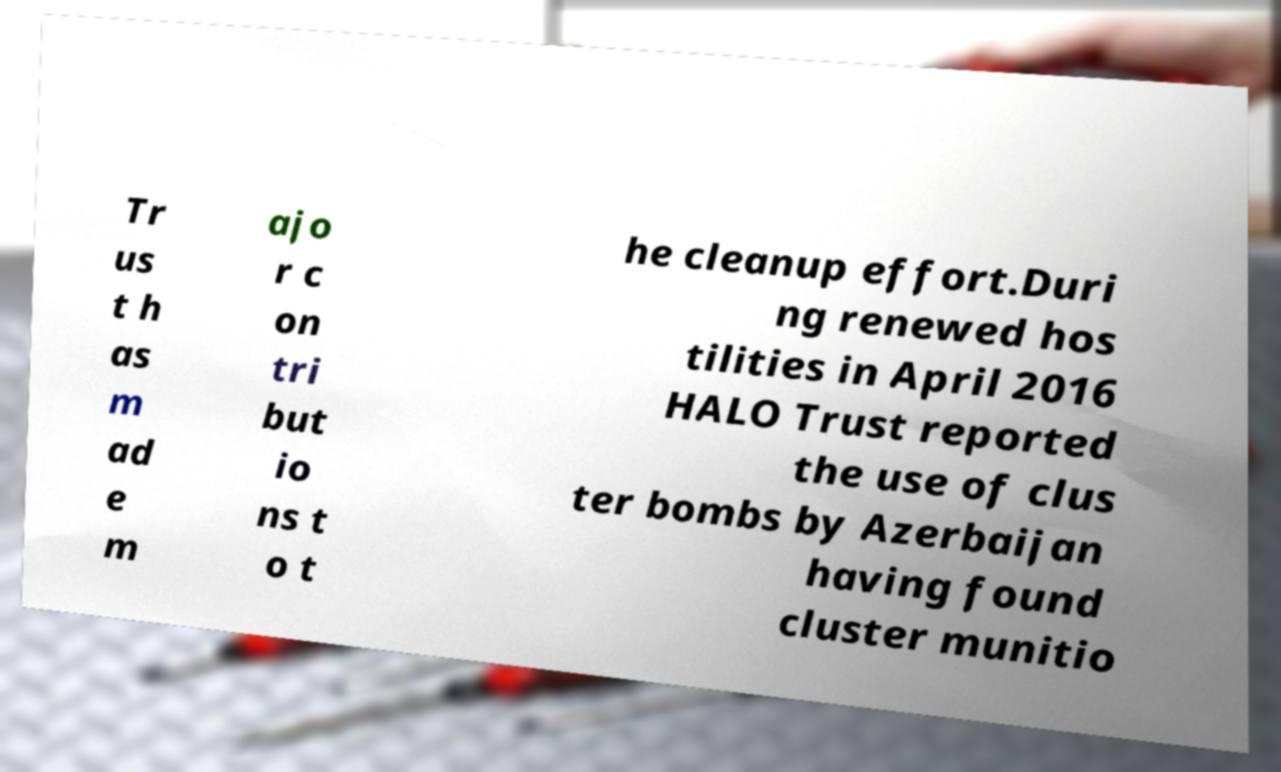Can you accurately transcribe the text from the provided image for me? Tr us t h as m ad e m ajo r c on tri but io ns t o t he cleanup effort.Duri ng renewed hos tilities in April 2016 HALO Trust reported the use of clus ter bombs by Azerbaijan having found cluster munitio 